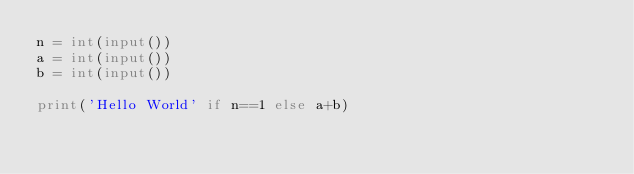<code> <loc_0><loc_0><loc_500><loc_500><_Python_>n = int(input())
a = int(input())
b = int(input())

print('Hello World' if n==1 else a+b)
</code> 